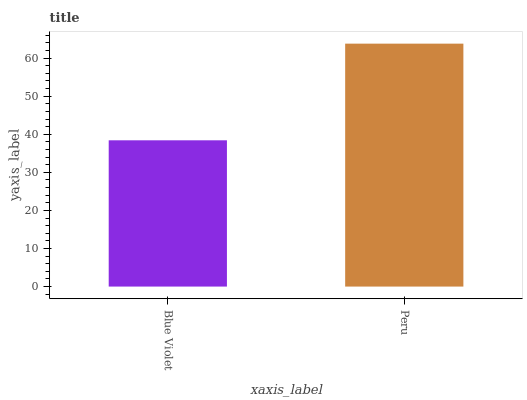Is Blue Violet the minimum?
Answer yes or no. Yes. Is Peru the maximum?
Answer yes or no. Yes. Is Peru the minimum?
Answer yes or no. No. Is Peru greater than Blue Violet?
Answer yes or no. Yes. Is Blue Violet less than Peru?
Answer yes or no. Yes. Is Blue Violet greater than Peru?
Answer yes or no. No. Is Peru less than Blue Violet?
Answer yes or no. No. Is Peru the high median?
Answer yes or no. Yes. Is Blue Violet the low median?
Answer yes or no. Yes. Is Blue Violet the high median?
Answer yes or no. No. Is Peru the low median?
Answer yes or no. No. 